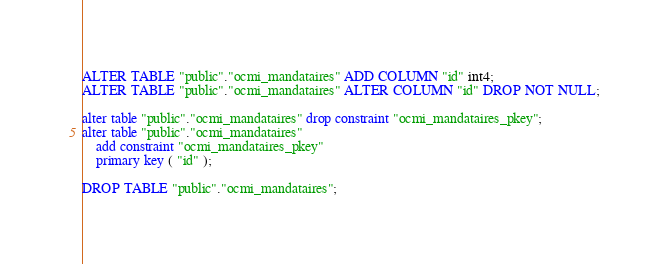Convert code to text. <code><loc_0><loc_0><loc_500><loc_500><_SQL_>
ALTER TABLE "public"."ocmi_mandataires" ADD COLUMN "id" int4;
ALTER TABLE "public"."ocmi_mandataires" ALTER COLUMN "id" DROP NOT NULL;

alter table "public"."ocmi_mandataires" drop constraint "ocmi_mandataires_pkey";
alter table "public"."ocmi_mandataires"
    add constraint "ocmi_mandataires_pkey" 
    primary key ( "id" );

DROP TABLE "public"."ocmi_mandataires";
</code> 